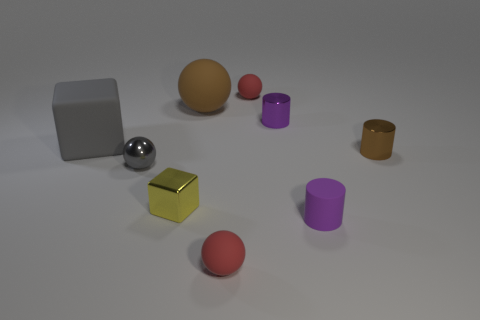Add 1 rubber cylinders. How many objects exist? 10 Subtract all small balls. How many balls are left? 1 Subtract 2 cubes. How many cubes are left? 0 Subtract all green cubes. How many red spheres are left? 2 Subtract all yellow blocks. How many blocks are left? 1 Subtract all balls. How many objects are left? 5 Subtract all gray cylinders. Subtract all purple blocks. How many cylinders are left? 3 Subtract all tiny gray metallic spheres. Subtract all purple objects. How many objects are left? 6 Add 7 purple shiny objects. How many purple shiny objects are left? 8 Add 2 gray metallic balls. How many gray metallic balls exist? 3 